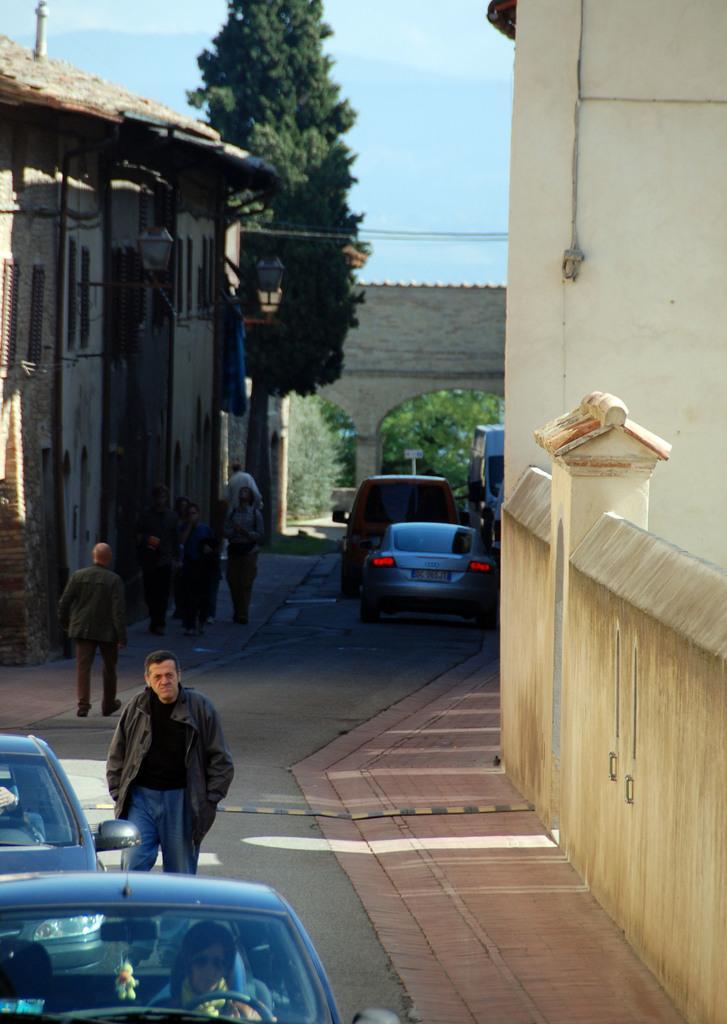In one or two sentences, can you explain what this image depicts? There is a group of people and cars present at the bottom of this image. We can see a house on the left side of this image and a wall on the right side of this image. We can see trees in the middle of this image. The sky is in the background. 